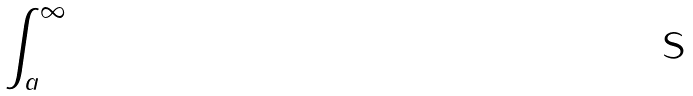<formula> <loc_0><loc_0><loc_500><loc_500>\int _ { a } ^ { \infty }</formula> 